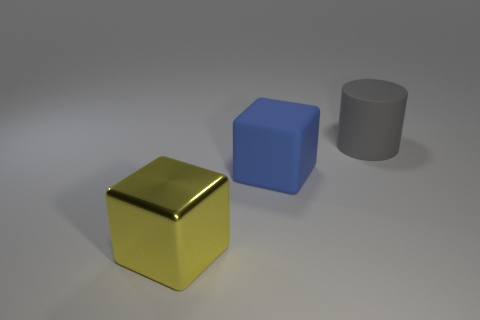There is a block that is to the right of the yellow metallic block; is its color the same as the metallic cube?
Give a very brief answer. No. Is the material of the large yellow object the same as the blue thing?
Ensure brevity in your answer.  No. Is the number of large blue blocks in front of the blue rubber thing the same as the number of big things on the right side of the large gray rubber cylinder?
Provide a succinct answer. Yes. There is another thing that is the same shape as the yellow metallic thing; what is its material?
Give a very brief answer. Rubber. There is a rubber thing that is in front of the rubber object that is behind the big matte thing in front of the matte cylinder; what shape is it?
Give a very brief answer. Cube. Is the number of gray rubber things on the left side of the rubber cylinder greater than the number of large red metal cylinders?
Your answer should be very brief. No. Is the shape of the matte object that is in front of the rubber cylinder the same as  the yellow thing?
Your answer should be compact. Yes. What material is the large cube behind the metallic cube?
Your answer should be very brief. Rubber. How many gray rubber objects have the same shape as the yellow object?
Give a very brief answer. 0. The large cube that is behind the large cube in front of the blue cube is made of what material?
Give a very brief answer. Rubber. 